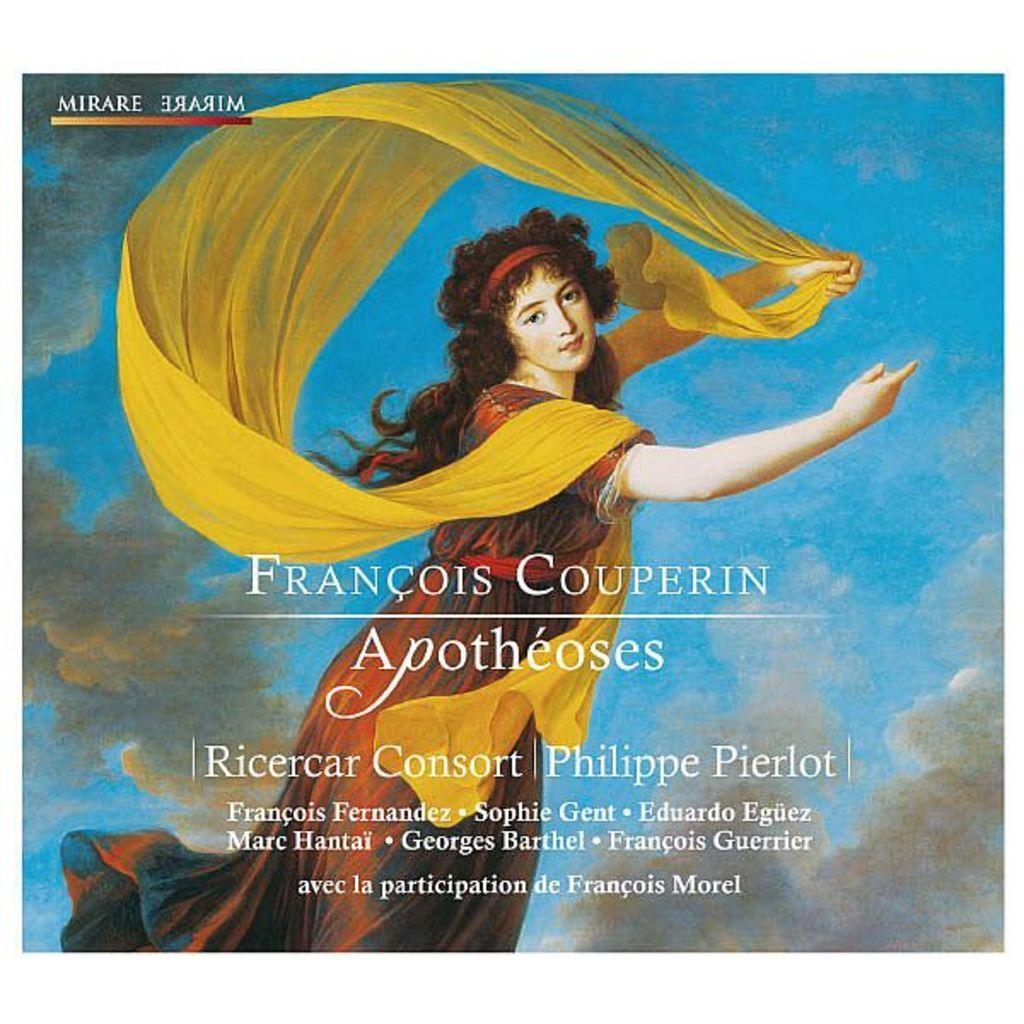<image>
Share a concise interpretation of the image provided. A poster by Francois Couperin Apotheoses shows a woman wearing a yellow scarf 